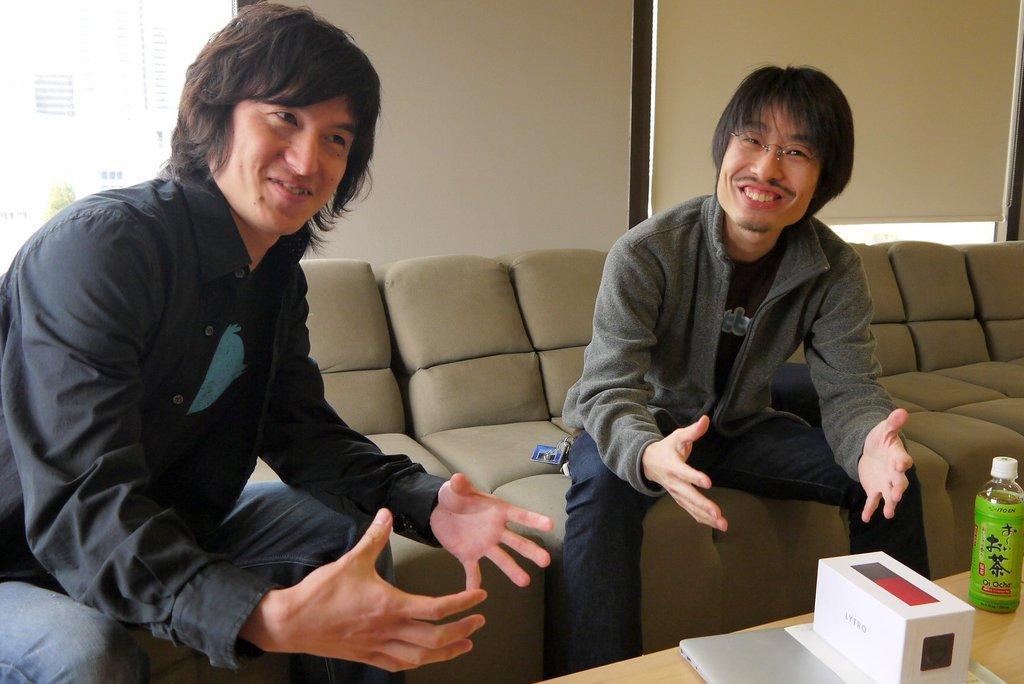Could you give a brief overview of what you see in this image? This picture shows two men Seated on the sofa bed and we see a bottle and a box and a laptop on the table. 